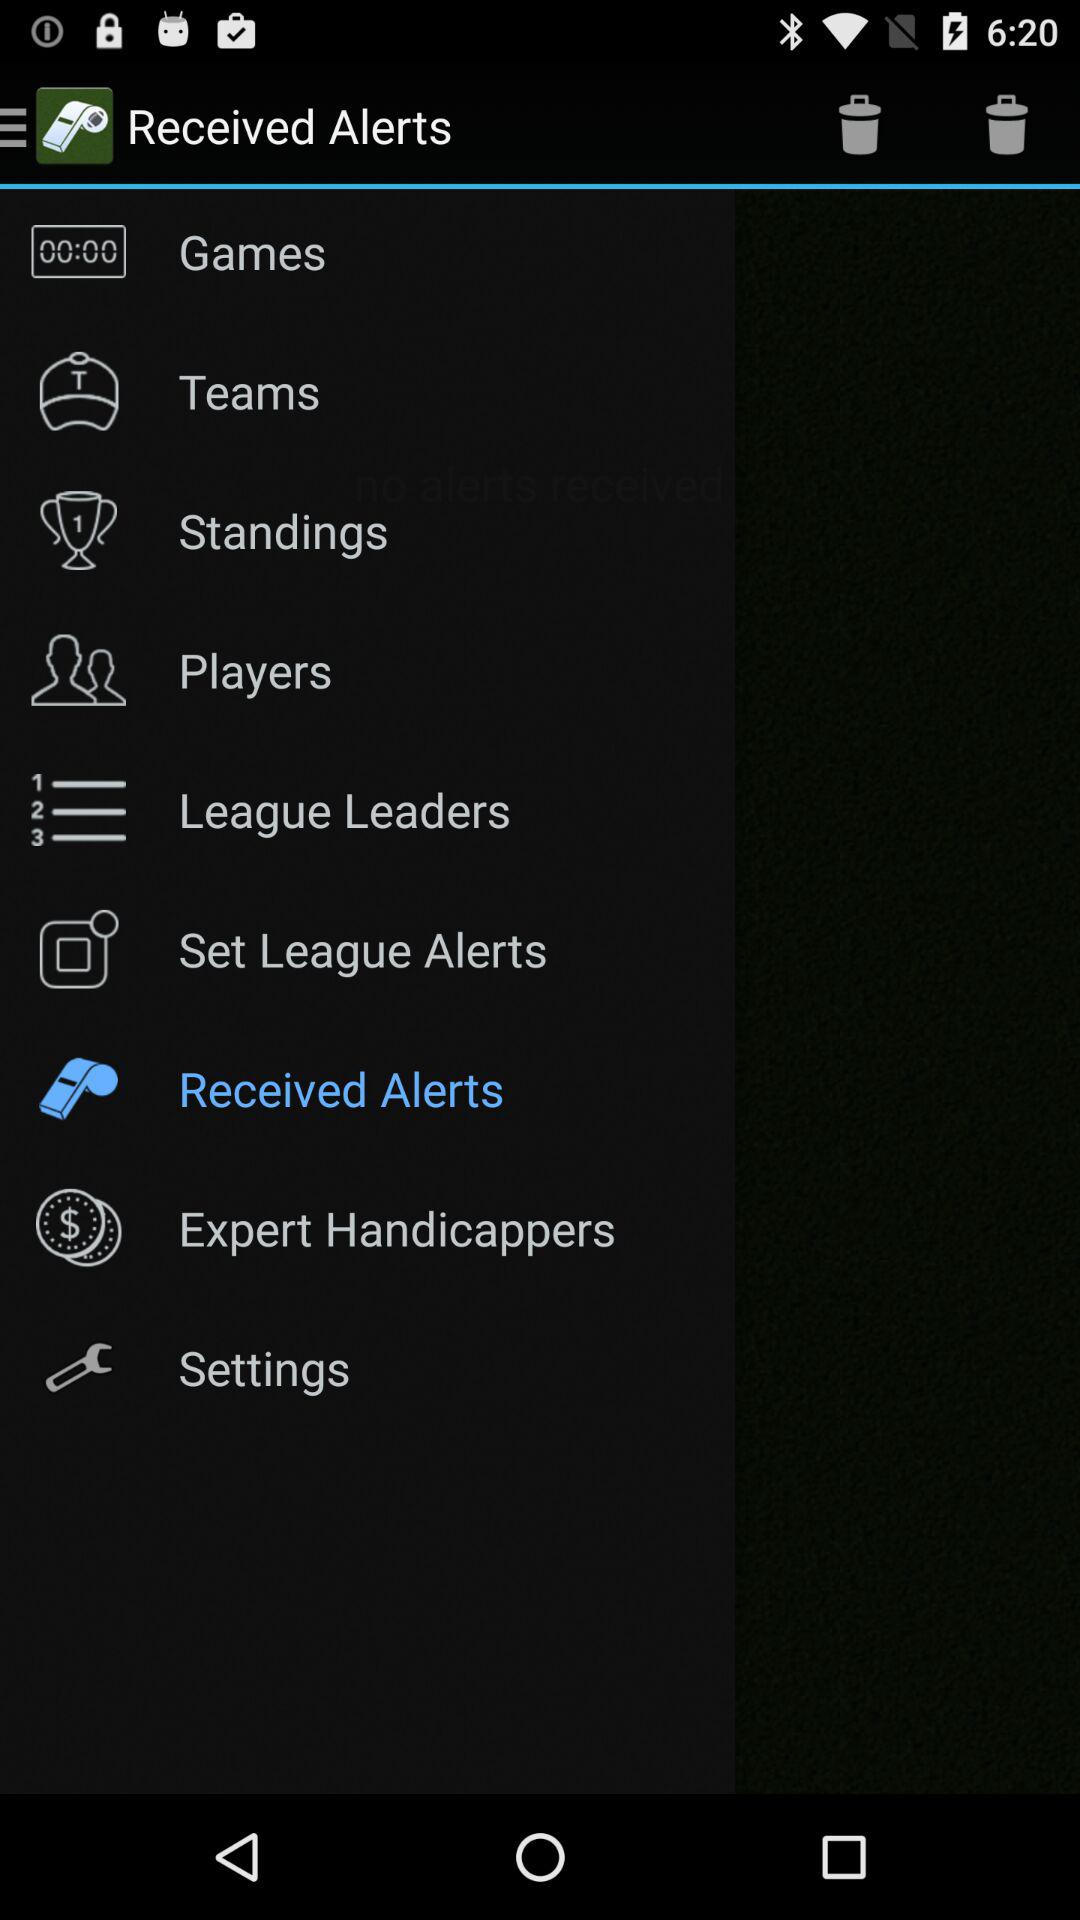Who are the league leaders?
When the provided information is insufficient, respond with <no answer>. <no answer> 